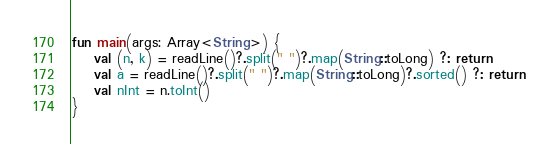Convert code to text. <code><loc_0><loc_0><loc_500><loc_500><_Kotlin_>fun main(args: Array<String>) {
    val (n, k) = readLine()?.split(" ")?.map(String::toLong) ?: return
    val a = readLine()?.split(" ")?.map(String::toLong)?.sorted() ?: return
    val nInt = n.toInt()
}</code> 